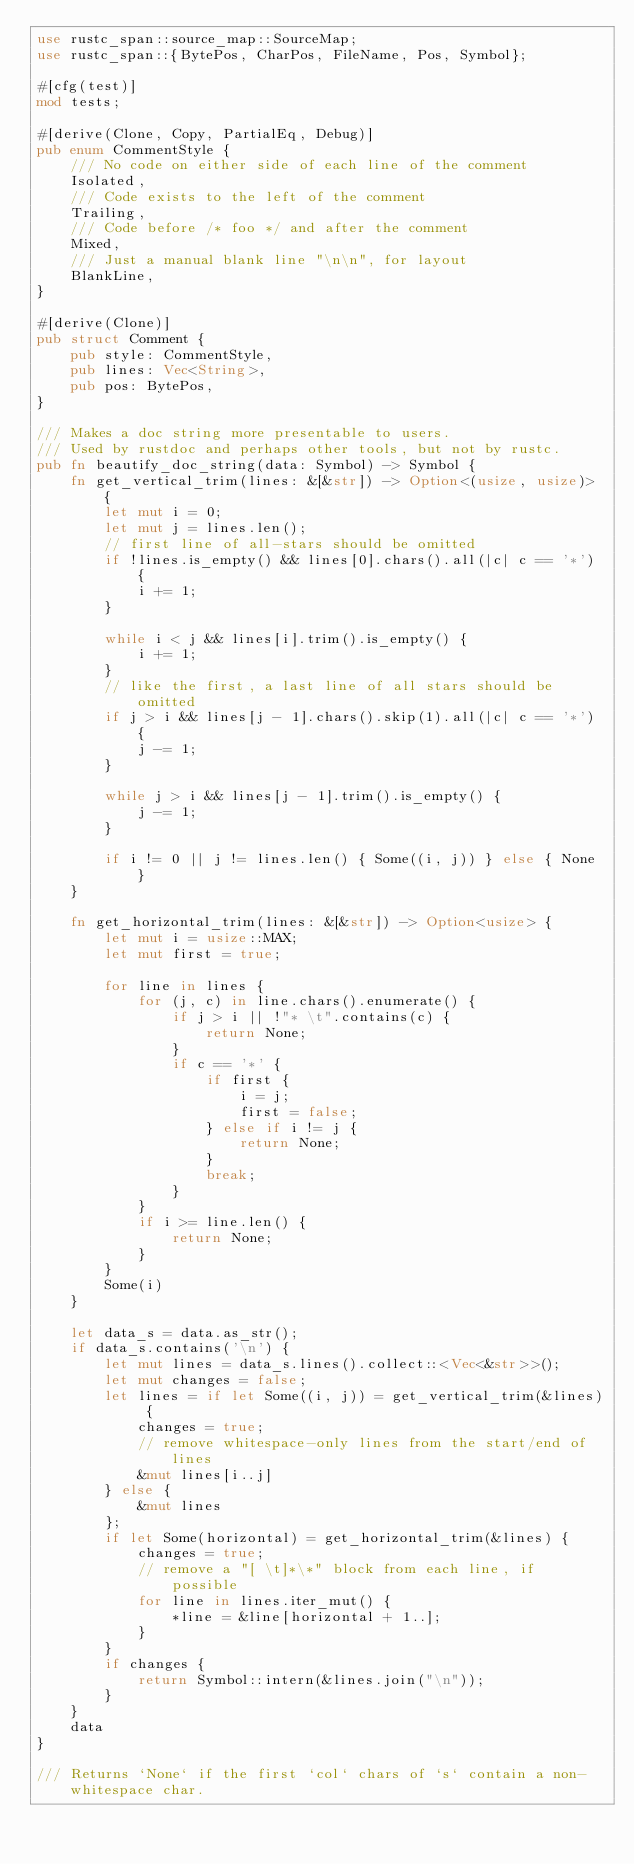Convert code to text. <code><loc_0><loc_0><loc_500><loc_500><_Rust_>use rustc_span::source_map::SourceMap;
use rustc_span::{BytePos, CharPos, FileName, Pos, Symbol};

#[cfg(test)]
mod tests;

#[derive(Clone, Copy, PartialEq, Debug)]
pub enum CommentStyle {
    /// No code on either side of each line of the comment
    Isolated,
    /// Code exists to the left of the comment
    Trailing,
    /// Code before /* foo */ and after the comment
    Mixed,
    /// Just a manual blank line "\n\n", for layout
    BlankLine,
}

#[derive(Clone)]
pub struct Comment {
    pub style: CommentStyle,
    pub lines: Vec<String>,
    pub pos: BytePos,
}

/// Makes a doc string more presentable to users.
/// Used by rustdoc and perhaps other tools, but not by rustc.
pub fn beautify_doc_string(data: Symbol) -> Symbol {
    fn get_vertical_trim(lines: &[&str]) -> Option<(usize, usize)> {
        let mut i = 0;
        let mut j = lines.len();
        // first line of all-stars should be omitted
        if !lines.is_empty() && lines[0].chars().all(|c| c == '*') {
            i += 1;
        }

        while i < j && lines[i].trim().is_empty() {
            i += 1;
        }
        // like the first, a last line of all stars should be omitted
        if j > i && lines[j - 1].chars().skip(1).all(|c| c == '*') {
            j -= 1;
        }

        while j > i && lines[j - 1].trim().is_empty() {
            j -= 1;
        }

        if i != 0 || j != lines.len() { Some((i, j)) } else { None }
    }

    fn get_horizontal_trim(lines: &[&str]) -> Option<usize> {
        let mut i = usize::MAX;
        let mut first = true;

        for line in lines {
            for (j, c) in line.chars().enumerate() {
                if j > i || !"* \t".contains(c) {
                    return None;
                }
                if c == '*' {
                    if first {
                        i = j;
                        first = false;
                    } else if i != j {
                        return None;
                    }
                    break;
                }
            }
            if i >= line.len() {
                return None;
            }
        }
        Some(i)
    }

    let data_s = data.as_str();
    if data_s.contains('\n') {
        let mut lines = data_s.lines().collect::<Vec<&str>>();
        let mut changes = false;
        let lines = if let Some((i, j)) = get_vertical_trim(&lines) {
            changes = true;
            // remove whitespace-only lines from the start/end of lines
            &mut lines[i..j]
        } else {
            &mut lines
        };
        if let Some(horizontal) = get_horizontal_trim(&lines) {
            changes = true;
            // remove a "[ \t]*\*" block from each line, if possible
            for line in lines.iter_mut() {
                *line = &line[horizontal + 1..];
            }
        }
        if changes {
            return Symbol::intern(&lines.join("\n"));
        }
    }
    data
}

/// Returns `None` if the first `col` chars of `s` contain a non-whitespace char.</code> 